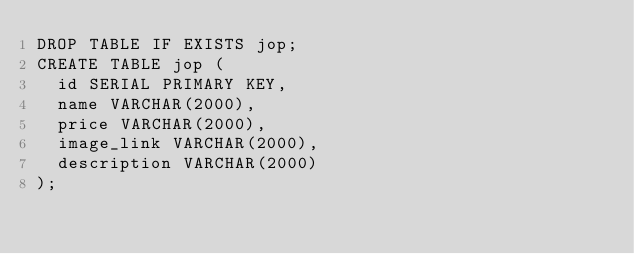<code> <loc_0><loc_0><loc_500><loc_500><_SQL_>DROP TABLE IF EXISTS jop;
CREATE TABLE jop (
  id SERIAL PRIMARY KEY,
  name VARCHAR(2000),
  price VARCHAR(2000),
  image_link VARCHAR(2000),
  description VARCHAR(2000)
);</code> 